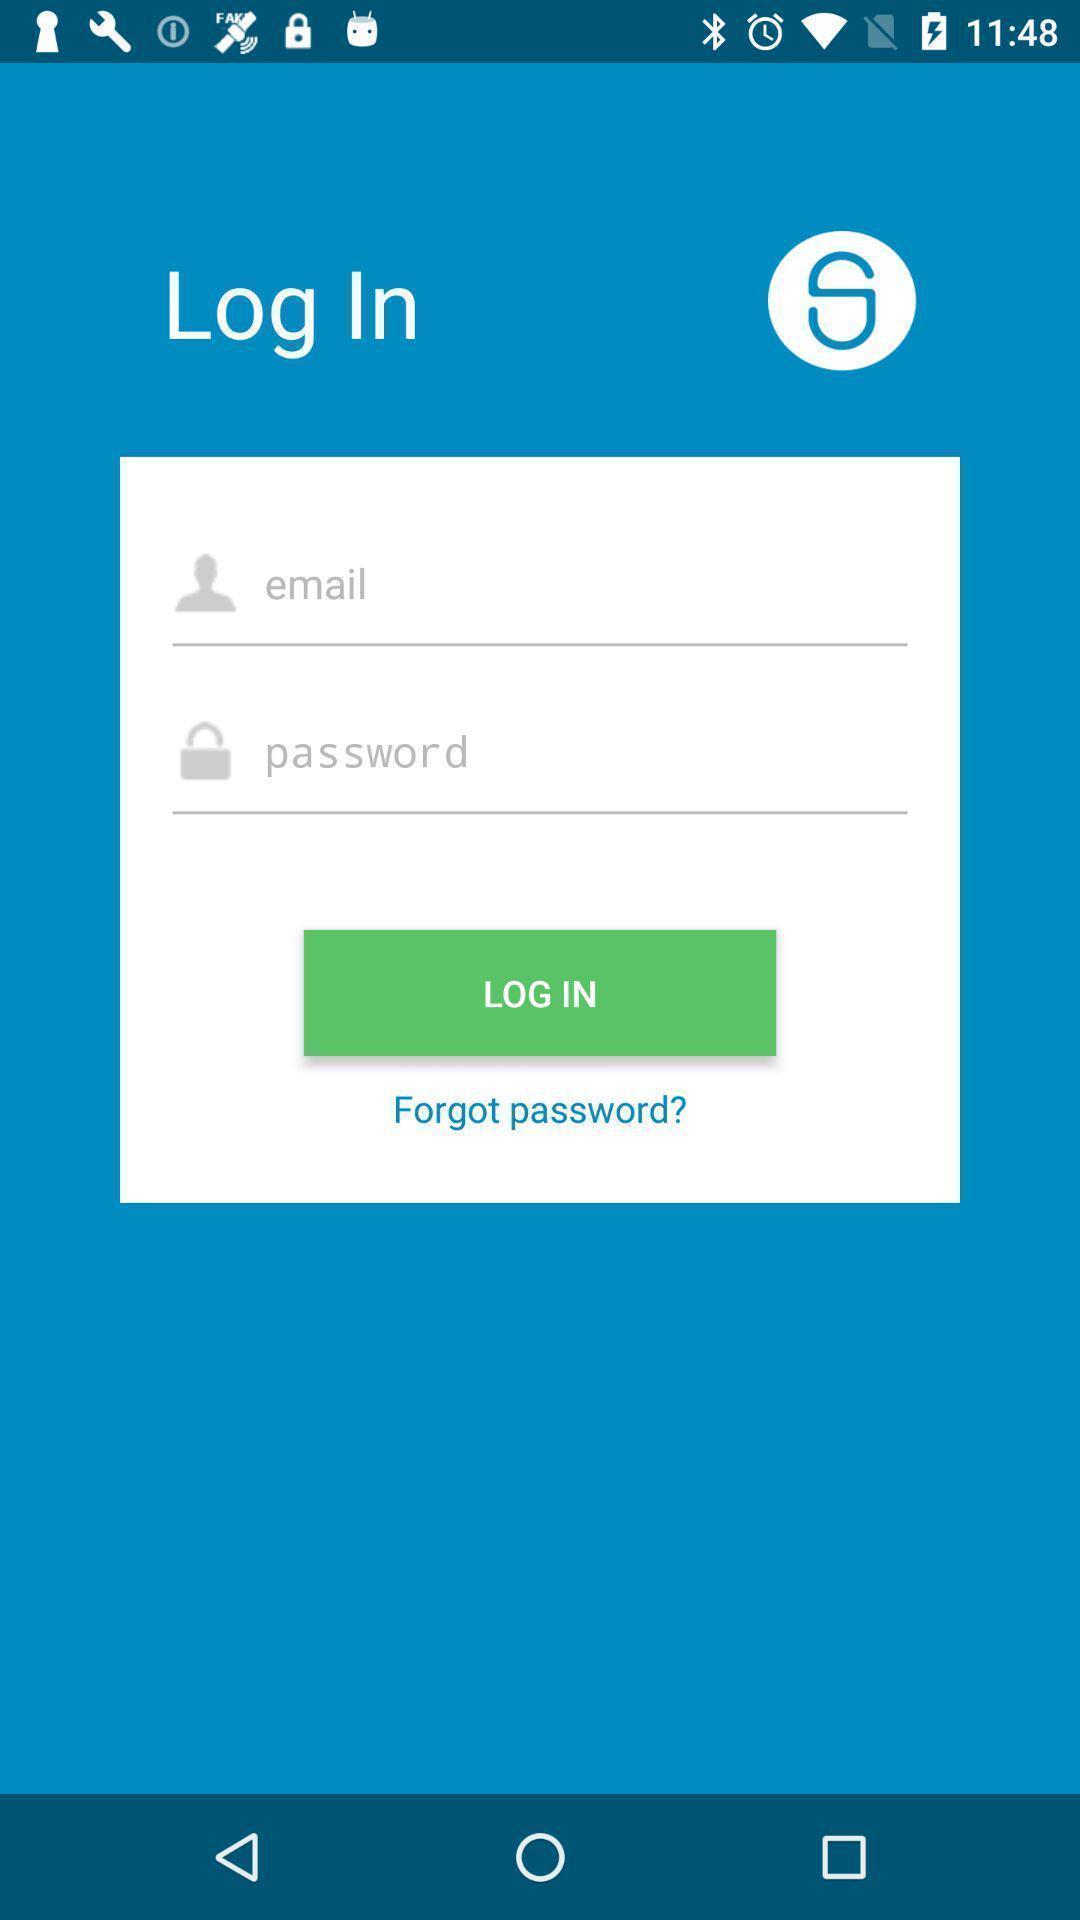Tell me what you see in this picture. Screen displaying a login page. 